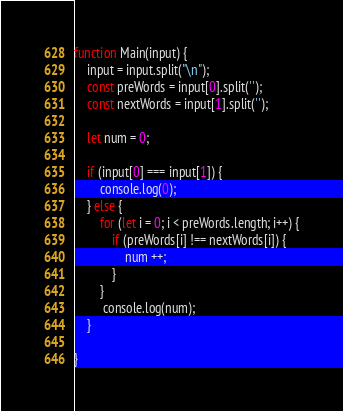<code> <loc_0><loc_0><loc_500><loc_500><_JavaScript_>function Main(input) {
    input = input.split("\n");
    const preWords = input[0].split('');
    const nextWords = input[1].split('');
    
    let num = 0;

    if (input[0] === input[1]) {
        console.log(0);
    } else {
        for (let i = 0; i < preWords.length; i++) {
            if (preWords[i] !== nextWords[i]) {
                num ++;        
            }
        }
         console.log(num);
    }

}</code> 